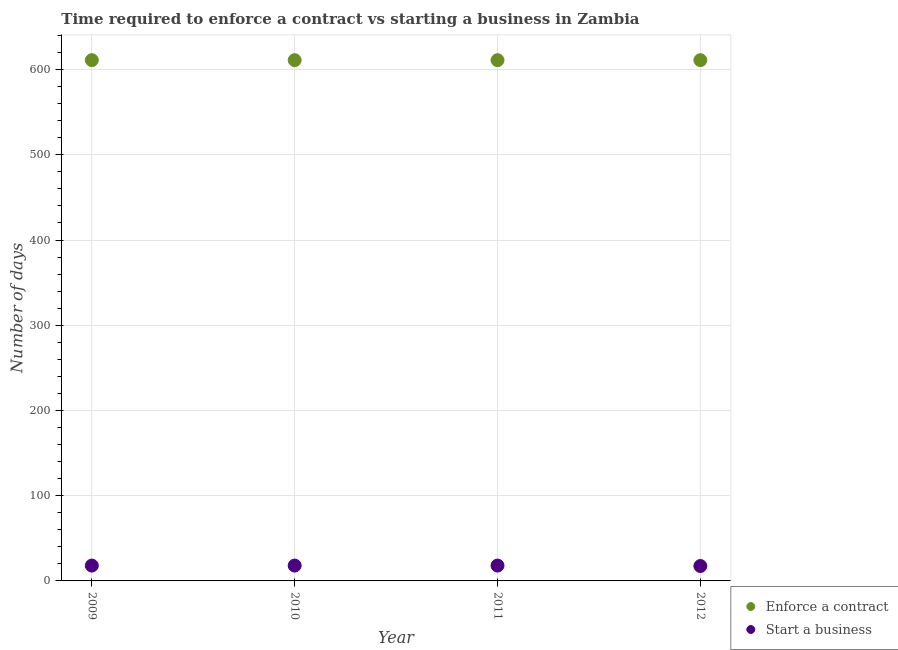Is the number of dotlines equal to the number of legend labels?
Provide a short and direct response. Yes. What is the number of days to enforece a contract in 2010?
Ensure brevity in your answer.  611. Across all years, what is the minimum number of days to enforece a contract?
Your answer should be very brief. 611. In which year was the number of days to enforece a contract minimum?
Give a very brief answer. 2009. What is the total number of days to start a business in the graph?
Offer a terse response. 71.5. What is the difference between the number of days to enforece a contract in 2010 and the number of days to start a business in 2009?
Offer a terse response. 593. What is the average number of days to start a business per year?
Make the answer very short. 17.88. In the year 2010, what is the difference between the number of days to start a business and number of days to enforece a contract?
Your answer should be compact. -593. In how many years, is the number of days to start a business greater than 40 days?
Make the answer very short. 0. Is the difference between the number of days to start a business in 2011 and 2012 greater than the difference between the number of days to enforece a contract in 2011 and 2012?
Provide a short and direct response. Yes. What is the difference between the highest and the second highest number of days to enforece a contract?
Ensure brevity in your answer.  0. What is the difference between the highest and the lowest number of days to enforece a contract?
Keep it short and to the point. 0. Is the sum of the number of days to enforece a contract in 2010 and 2012 greater than the maximum number of days to start a business across all years?
Offer a very short reply. Yes. Is the number of days to enforece a contract strictly greater than the number of days to start a business over the years?
Provide a short and direct response. Yes. Is the number of days to enforece a contract strictly less than the number of days to start a business over the years?
Your answer should be compact. No. How many years are there in the graph?
Provide a succinct answer. 4. Does the graph contain any zero values?
Make the answer very short. No. Does the graph contain grids?
Provide a short and direct response. Yes. Where does the legend appear in the graph?
Make the answer very short. Bottom right. How many legend labels are there?
Offer a terse response. 2. What is the title of the graph?
Offer a very short reply. Time required to enforce a contract vs starting a business in Zambia. Does "Young" appear as one of the legend labels in the graph?
Give a very brief answer. No. What is the label or title of the Y-axis?
Ensure brevity in your answer.  Number of days. What is the Number of days in Enforce a contract in 2009?
Your answer should be very brief. 611. What is the Number of days in Enforce a contract in 2010?
Ensure brevity in your answer.  611. What is the Number of days of Start a business in 2010?
Give a very brief answer. 18. What is the Number of days in Enforce a contract in 2011?
Make the answer very short. 611. What is the Number of days in Start a business in 2011?
Ensure brevity in your answer.  18. What is the Number of days in Enforce a contract in 2012?
Offer a very short reply. 611. Across all years, what is the maximum Number of days in Enforce a contract?
Your answer should be very brief. 611. Across all years, what is the minimum Number of days in Enforce a contract?
Your response must be concise. 611. Across all years, what is the minimum Number of days in Start a business?
Ensure brevity in your answer.  17.5. What is the total Number of days in Enforce a contract in the graph?
Offer a terse response. 2444. What is the total Number of days in Start a business in the graph?
Provide a short and direct response. 71.5. What is the difference between the Number of days in Enforce a contract in 2009 and that in 2010?
Your answer should be compact. 0. What is the difference between the Number of days of Start a business in 2009 and that in 2010?
Provide a succinct answer. 0. What is the difference between the Number of days in Start a business in 2009 and that in 2012?
Offer a terse response. 0.5. What is the difference between the Number of days of Enforce a contract in 2010 and that in 2011?
Make the answer very short. 0. What is the difference between the Number of days of Start a business in 2010 and that in 2011?
Offer a very short reply. 0. What is the difference between the Number of days in Start a business in 2010 and that in 2012?
Ensure brevity in your answer.  0.5. What is the difference between the Number of days in Enforce a contract in 2011 and that in 2012?
Your response must be concise. 0. What is the difference between the Number of days of Enforce a contract in 2009 and the Number of days of Start a business in 2010?
Make the answer very short. 593. What is the difference between the Number of days in Enforce a contract in 2009 and the Number of days in Start a business in 2011?
Offer a terse response. 593. What is the difference between the Number of days of Enforce a contract in 2009 and the Number of days of Start a business in 2012?
Offer a terse response. 593.5. What is the difference between the Number of days of Enforce a contract in 2010 and the Number of days of Start a business in 2011?
Keep it short and to the point. 593. What is the difference between the Number of days of Enforce a contract in 2010 and the Number of days of Start a business in 2012?
Your answer should be very brief. 593.5. What is the difference between the Number of days of Enforce a contract in 2011 and the Number of days of Start a business in 2012?
Offer a terse response. 593.5. What is the average Number of days of Enforce a contract per year?
Offer a terse response. 611. What is the average Number of days of Start a business per year?
Make the answer very short. 17.88. In the year 2009, what is the difference between the Number of days of Enforce a contract and Number of days of Start a business?
Give a very brief answer. 593. In the year 2010, what is the difference between the Number of days of Enforce a contract and Number of days of Start a business?
Give a very brief answer. 593. In the year 2011, what is the difference between the Number of days in Enforce a contract and Number of days in Start a business?
Give a very brief answer. 593. In the year 2012, what is the difference between the Number of days in Enforce a contract and Number of days in Start a business?
Your response must be concise. 593.5. What is the ratio of the Number of days of Enforce a contract in 2009 to that in 2010?
Your answer should be very brief. 1. What is the ratio of the Number of days of Enforce a contract in 2009 to that in 2012?
Keep it short and to the point. 1. What is the ratio of the Number of days in Start a business in 2009 to that in 2012?
Offer a terse response. 1.03. What is the ratio of the Number of days of Start a business in 2010 to that in 2011?
Provide a short and direct response. 1. What is the ratio of the Number of days of Enforce a contract in 2010 to that in 2012?
Keep it short and to the point. 1. What is the ratio of the Number of days of Start a business in 2010 to that in 2012?
Offer a very short reply. 1.03. What is the ratio of the Number of days of Enforce a contract in 2011 to that in 2012?
Make the answer very short. 1. What is the ratio of the Number of days in Start a business in 2011 to that in 2012?
Your response must be concise. 1.03. What is the difference between the highest and the second highest Number of days of Enforce a contract?
Your answer should be very brief. 0. What is the difference between the highest and the second highest Number of days of Start a business?
Your response must be concise. 0. What is the difference between the highest and the lowest Number of days in Start a business?
Your response must be concise. 0.5. 